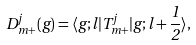Convert formula to latex. <formula><loc_0><loc_0><loc_500><loc_500>D ^ { j } _ { m + } ( g ) = \langle g ; l | T ^ { j } _ { m + } | g ; l + \frac { 1 } { 2 } \rangle ,</formula> 